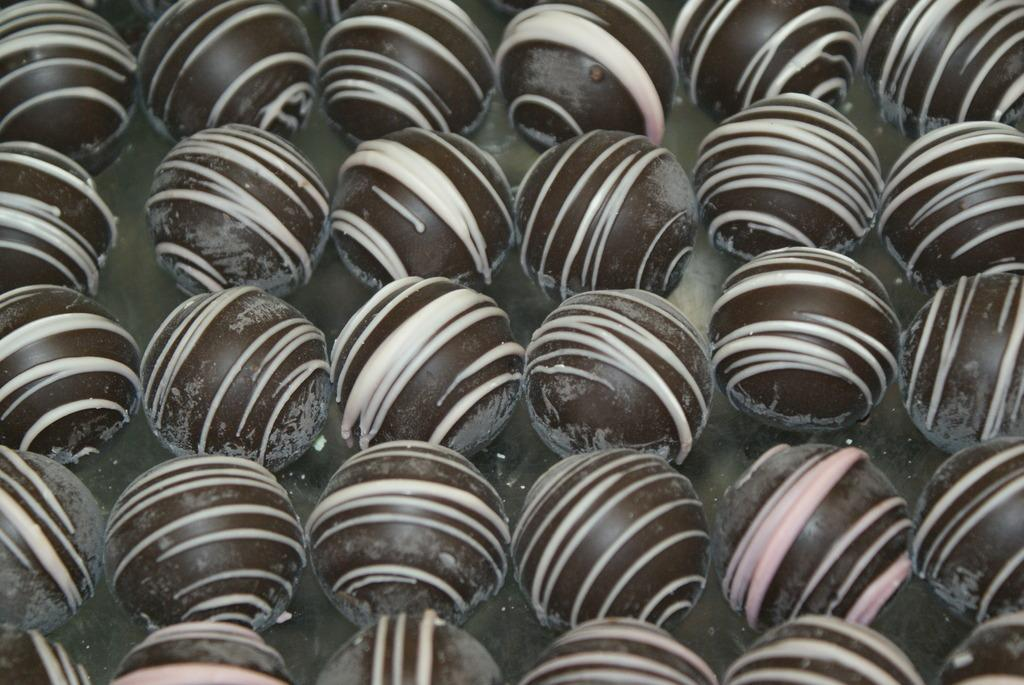What is the shape of the objects in the image? The objects in the image are round shaped. Where are the round shaped objects located? The round shaped objects are on a surface. What type of brush is being used in the discussion in the image? There is no discussion or brush present in the image; it only features round shaped objects on a surface. 